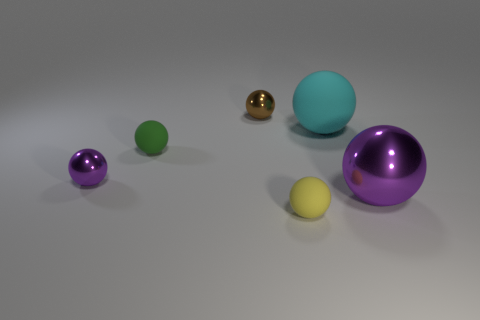Are there more large purple spheres to the left of the large cyan matte thing than shiny spheres left of the yellow thing?
Offer a very short reply. No. What material is the tiny thing that is the same color as the big metallic object?
Offer a very short reply. Metal. Is there anything else that is the same shape as the brown thing?
Keep it short and to the point. Yes. What is the object that is right of the yellow matte thing and on the left side of the large shiny ball made of?
Ensure brevity in your answer.  Rubber. Are the big cyan ball and the brown sphere on the right side of the green rubber thing made of the same material?
Give a very brief answer. No. Is there any other thing that has the same size as the cyan matte ball?
Your answer should be very brief. Yes. How many things are either shiny spheres or rubber objects behind the small yellow matte object?
Keep it short and to the point. 5. Do the purple metal ball left of the small yellow matte ball and the purple shiny ball that is to the right of the small green matte ball have the same size?
Make the answer very short. No. How many other objects are the same color as the big rubber object?
Provide a succinct answer. 0. Do the cyan ball and the metallic sphere on the left side of the tiny brown metallic sphere have the same size?
Provide a short and direct response. No. 